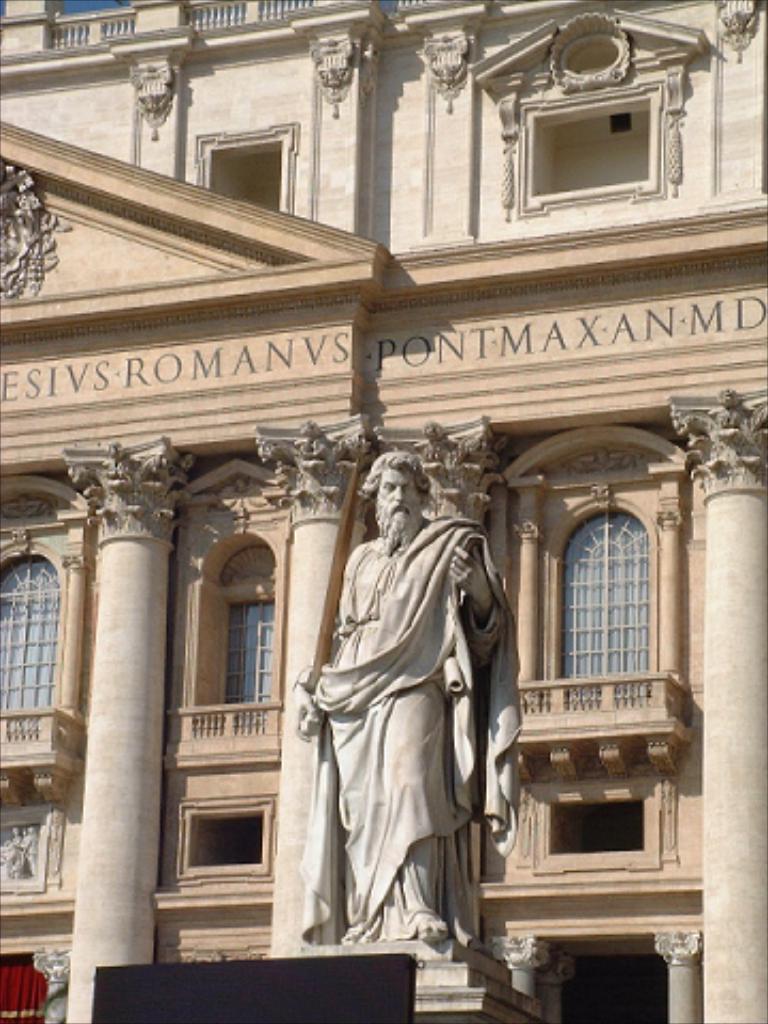How would you summarize this image in a sentence or two? This picture is clicked outside. In the center we can see the sculpture of a man standing and holding some object. In the background we can see the text on the building and we can see the windows and pillars of the building and we can see some other objects. 